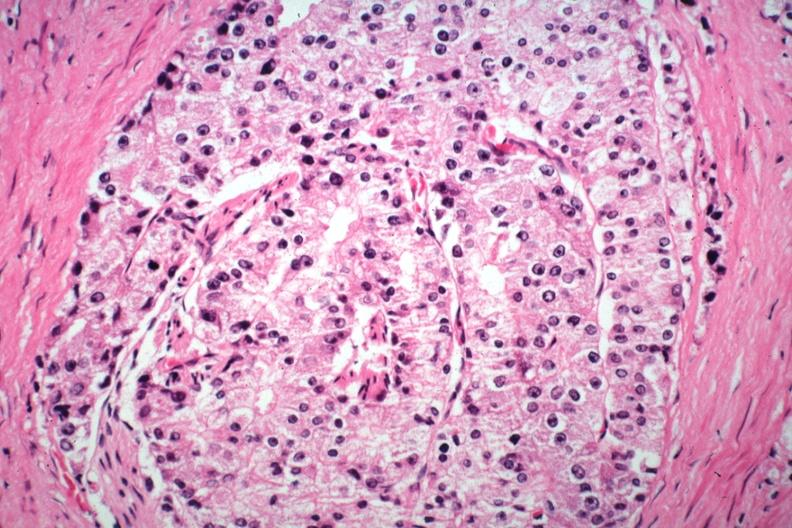what is present?
Answer the question using a single word or phrase. Prostate 